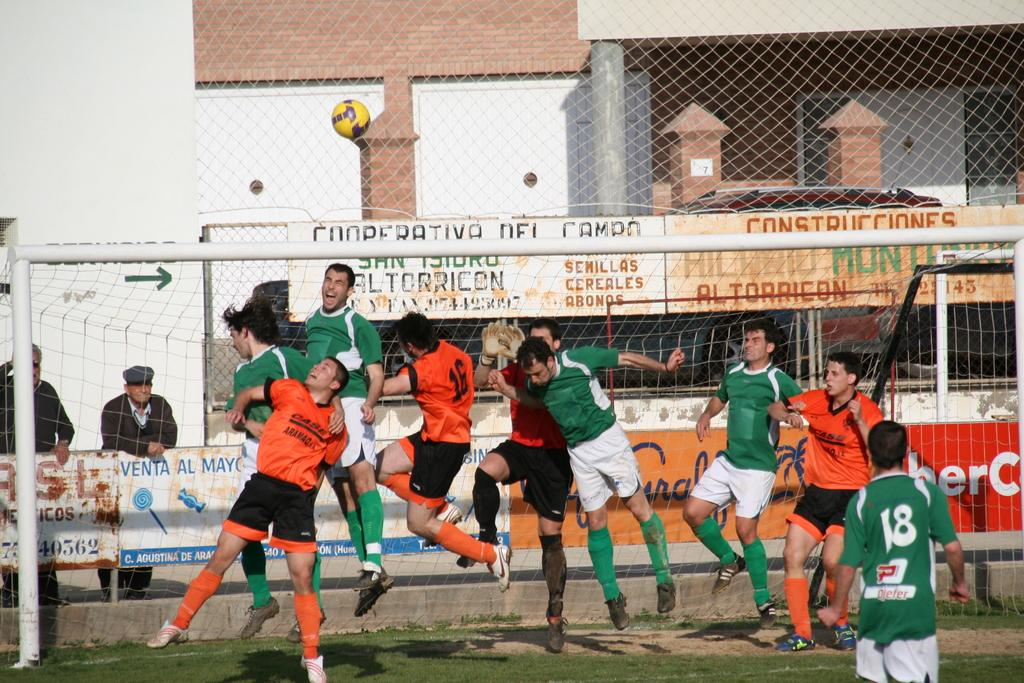<image>
Share a concise interpretation of the image provided. two volleyball teams playing a game with a sign cooperativa del campo behind them 